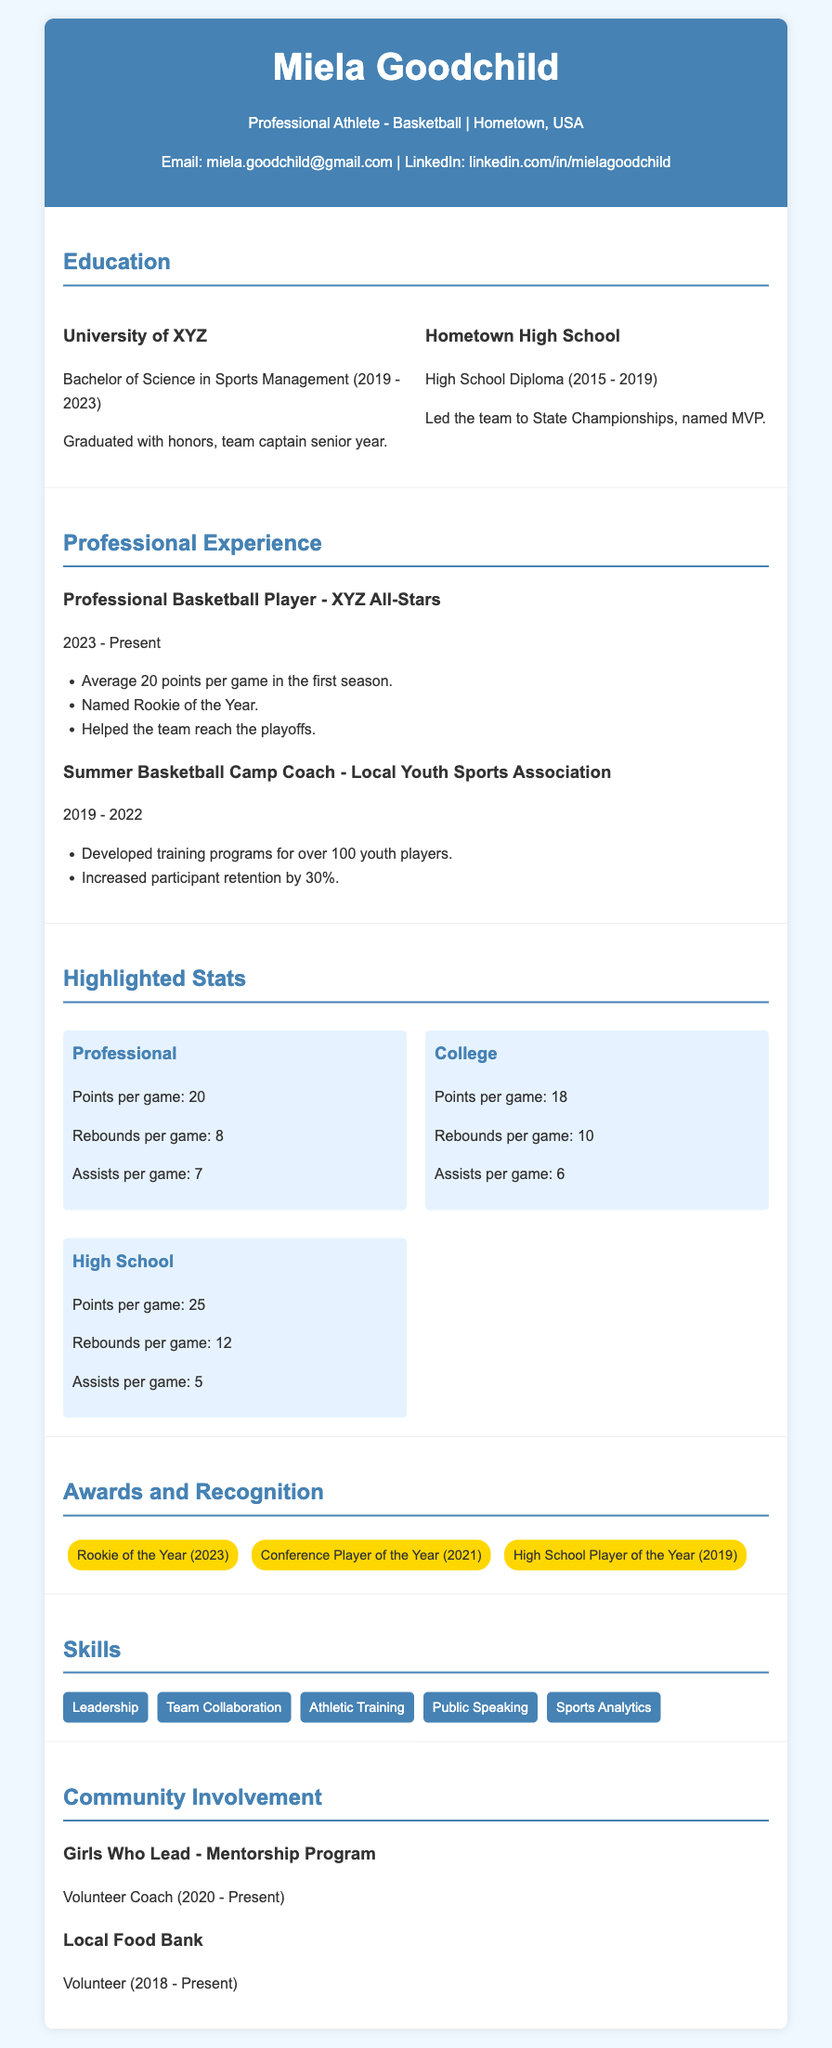What is Miela Goodchild's major? The document states that she has a Bachelor of Science in Sports Management.
Answer: Sports Management Where did Miela attend high school? The CV mentions that she graduated from Hometown High School.
Answer: Hometown High School Which team did Miela play for professionally? The document states she is a player for the XYZ All-Stars.
Answer: XYZ All-Stars What was Miela's average points per game in her first professional season? The document indicates that she averaged 20 points per game.
Answer: 20 What honor did Miela receive in 2023? The CV highlights that she was named Rookie of the Year.
Answer: Rookie of the Year How many rebounds per game did Miela average in high school? The document provides the statistic of 12 rebounds per game for high school.
Answer: 12 What percentage of participant retention did Miela achieve as a camp coach? It states that she increased participant retention by 30%.
Answer: 30% What role does Miela have in the mentorship program? The document mentions that she is a Volunteer Coach.
Answer: Volunteer Coach Which award did she win in 2021? The CV lists her as the Conference Player of the Year for that year.
Answer: Conference Player of the Year 